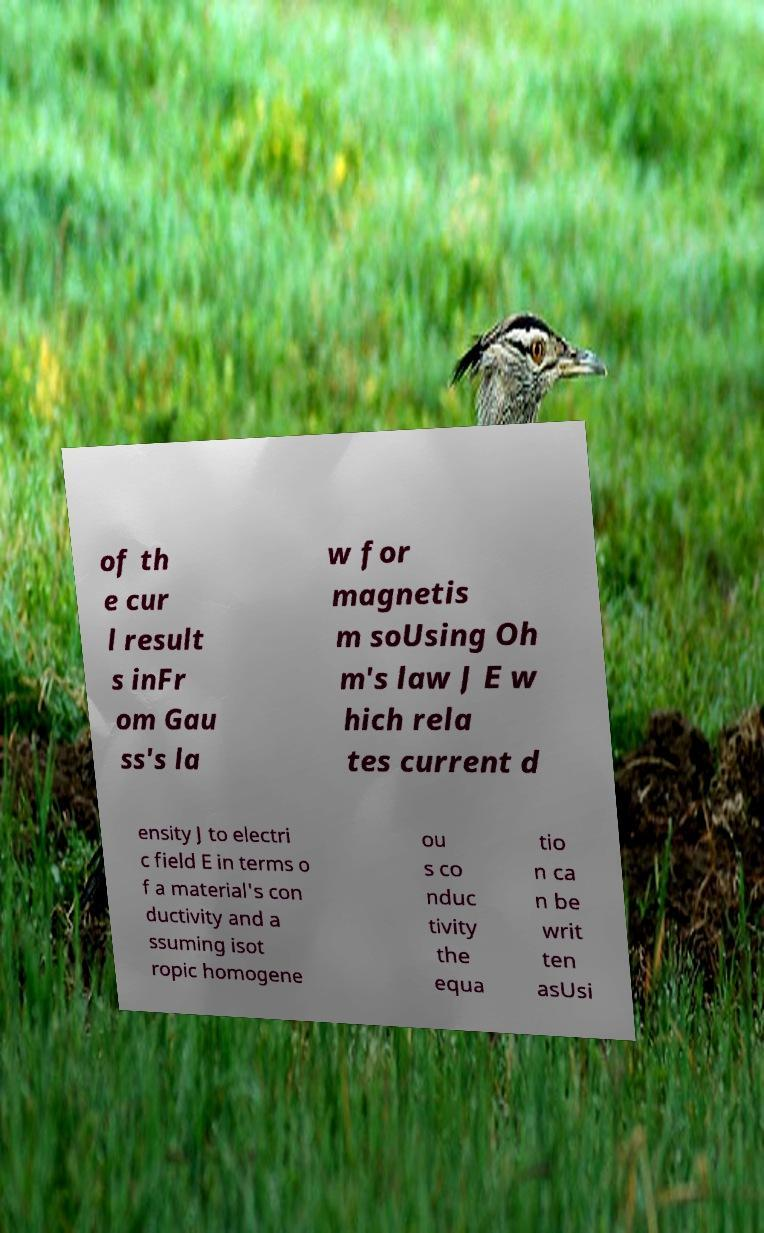Can you accurately transcribe the text from the provided image for me? of th e cur l result s inFr om Gau ss's la w for magnetis m soUsing Oh m's law J E w hich rela tes current d ensity J to electri c field E in terms o f a material's con ductivity and a ssuming isot ropic homogene ou s co nduc tivity the equa tio n ca n be writ ten asUsi 